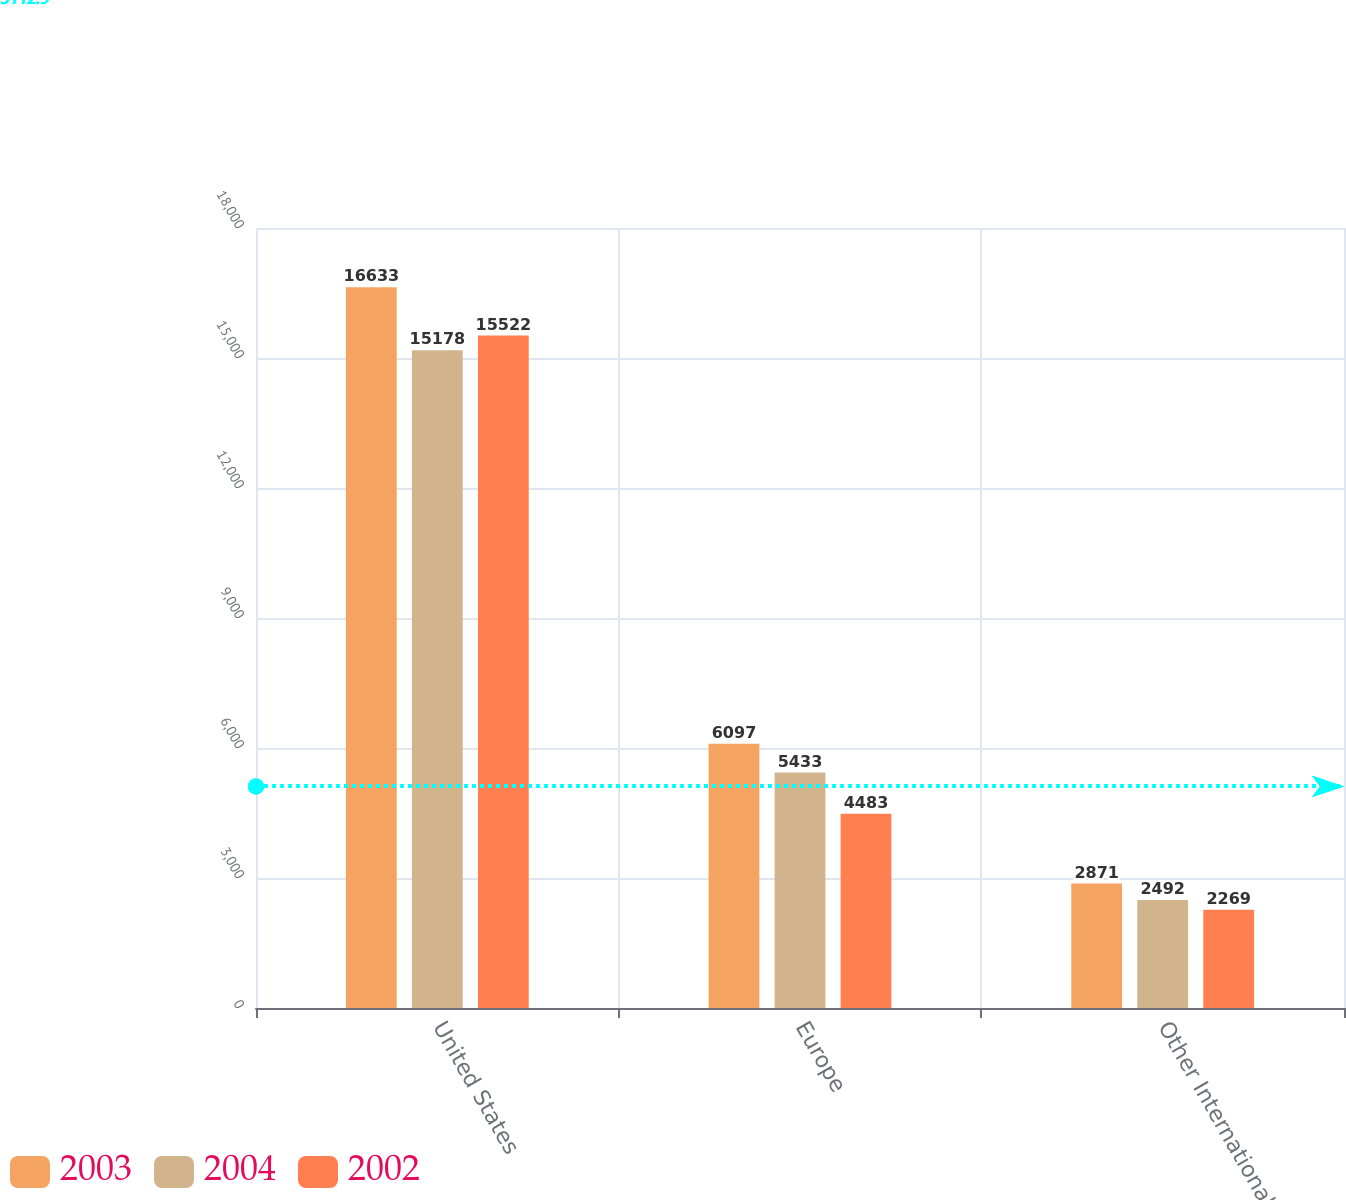<chart> <loc_0><loc_0><loc_500><loc_500><stacked_bar_chart><ecel><fcel>United States<fcel>Europe<fcel>Other International<nl><fcel>2003<fcel>16633<fcel>6097<fcel>2871<nl><fcel>2004<fcel>15178<fcel>5433<fcel>2492<nl><fcel>2002<fcel>15522<fcel>4483<fcel>2269<nl></chart> 